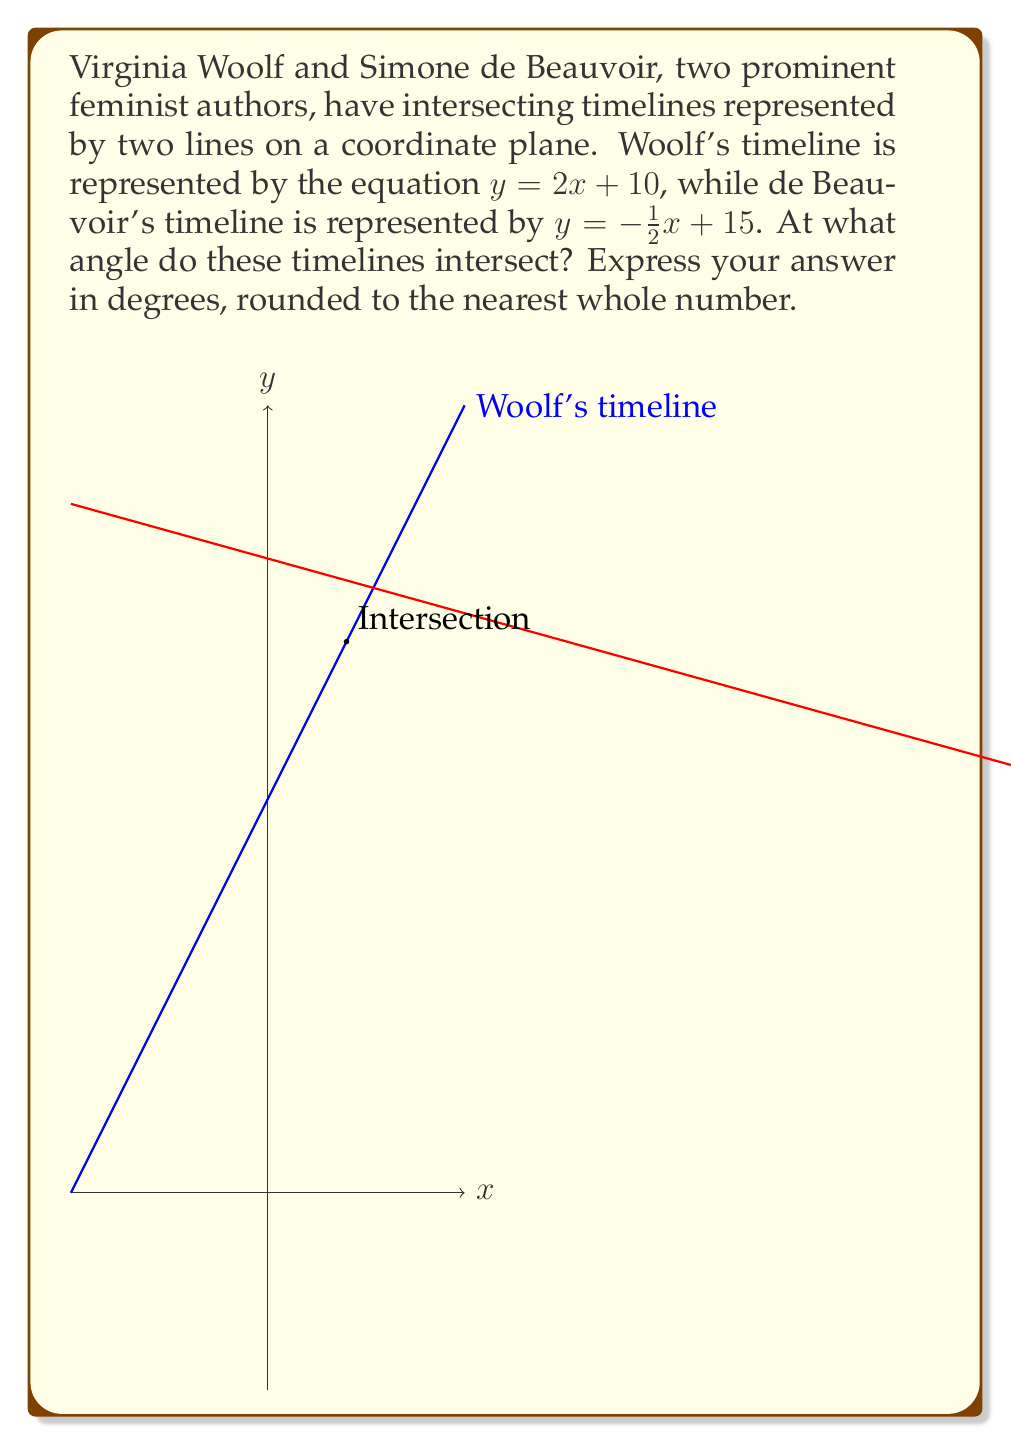Can you answer this question? To solve this problem, we'll follow these steps:

1) First, we need to find the slopes of both lines. 
   For Woolf's timeline: $m_1 = 2$
   For de Beauvoir's timeline: $m_2 = -\frac{1}{2}$

2) The angle between two lines can be found using the formula:

   $$\tan \theta = \left|\frac{m_1 - m_2}{1 + m_1m_2}\right|$$

3) Let's substitute our values:

   $$\tan \theta = \left|\frac{2 - (-\frac{1}{2})}{1 + 2(-\frac{1}{2})}\right| = \left|\frac{2 + \frac{1}{2}}{1 - 1}\right| = \left|\frac{\frac{5}{2}}{0}\right|$$

4) This results in an undefined value, which means the angle is 90°. This makes sense geometrically, as a line with a positive slope intersecting a line with a negative slope at right angles.

5) To verify, we can calculate the product of the slopes:
   $m_1 \cdot m_2 = 2 \cdot (-\frac{1}{2}) = -1$

   When the product of two slopes is -1, the lines are perpendicular.

Therefore, the timelines intersect at a 90° angle.
Answer: 90° 